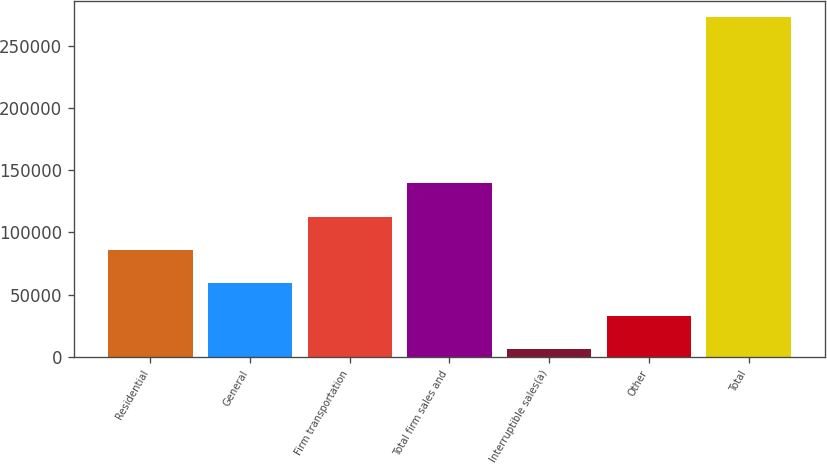Convert chart to OTSL. <chart><loc_0><loc_0><loc_500><loc_500><bar_chart><fcel>Residential<fcel>General<fcel>Firm transportation<fcel>Total firm sales and<fcel>Interruptible sales(a)<fcel>Other<fcel>Total<nl><fcel>85955.4<fcel>59290.6<fcel>112620<fcel>139285<fcel>5961<fcel>32625.8<fcel>272609<nl></chart> 